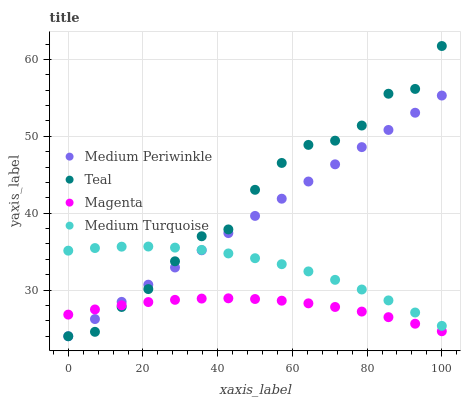Does Magenta have the minimum area under the curve?
Answer yes or no. Yes. Does Teal have the maximum area under the curve?
Answer yes or no. Yes. Does Medium Periwinkle have the minimum area under the curve?
Answer yes or no. No. Does Medium Periwinkle have the maximum area under the curve?
Answer yes or no. No. Is Medium Periwinkle the smoothest?
Answer yes or no. Yes. Is Teal the roughest?
Answer yes or no. Yes. Is Medium Turquoise the smoothest?
Answer yes or no. No. Is Medium Turquoise the roughest?
Answer yes or no. No. Does Medium Periwinkle have the lowest value?
Answer yes or no. Yes. Does Medium Turquoise have the lowest value?
Answer yes or no. No. Does Teal have the highest value?
Answer yes or no. Yes. Does Medium Periwinkle have the highest value?
Answer yes or no. No. Is Magenta less than Medium Turquoise?
Answer yes or no. Yes. Is Medium Turquoise greater than Magenta?
Answer yes or no. Yes. Does Medium Periwinkle intersect Medium Turquoise?
Answer yes or no. Yes. Is Medium Periwinkle less than Medium Turquoise?
Answer yes or no. No. Is Medium Periwinkle greater than Medium Turquoise?
Answer yes or no. No. Does Magenta intersect Medium Turquoise?
Answer yes or no. No. 